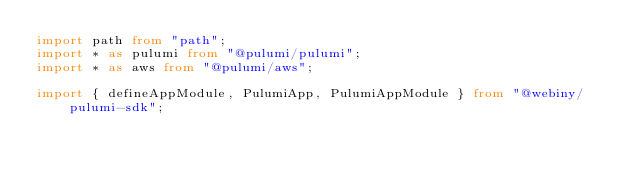Convert code to text. <code><loc_0><loc_0><loc_500><loc_500><_TypeScript_>import path from "path";
import * as pulumi from "@pulumi/pulumi";
import * as aws from "@pulumi/aws";

import { defineAppModule, PulumiApp, PulumiAppModule } from "@webiny/pulumi-sdk";</code> 